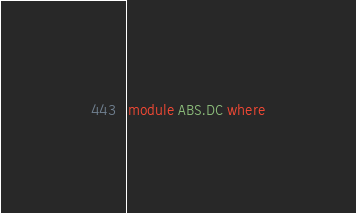Convert code to text. <code><loc_0><loc_0><loc_500><loc_500><_Haskell_>module ABS.DC where
</code> 